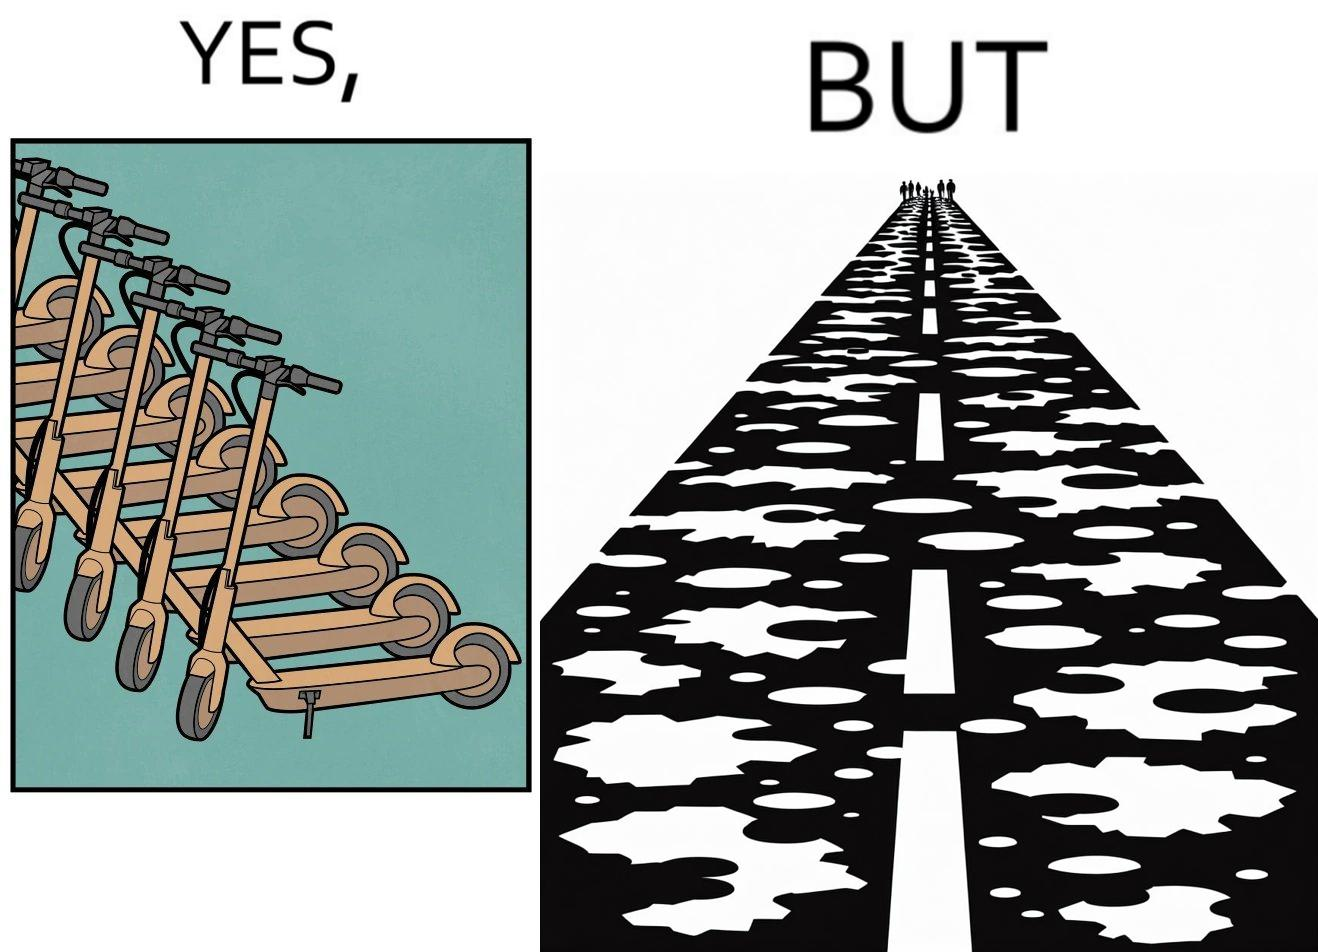Explain why this image is satirical. The image is ironic, because even after when the skateboard scooters are available for someone to ride but the road has many potholes that it is not suitable to ride the scooters on such roads 